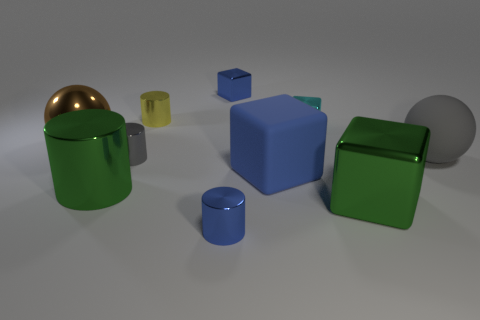Subtract 1 cubes. How many cubes are left? 3 Subtract all red cylinders. Subtract all cyan spheres. How many cylinders are left? 4 Subtract all cylinders. How many objects are left? 6 Add 7 cyan cubes. How many cyan cubes are left? 8 Add 10 tiny purple metallic objects. How many tiny purple metallic objects exist? 10 Subtract 0 yellow balls. How many objects are left? 10 Subtract all small gray shiny cylinders. Subtract all green objects. How many objects are left? 7 